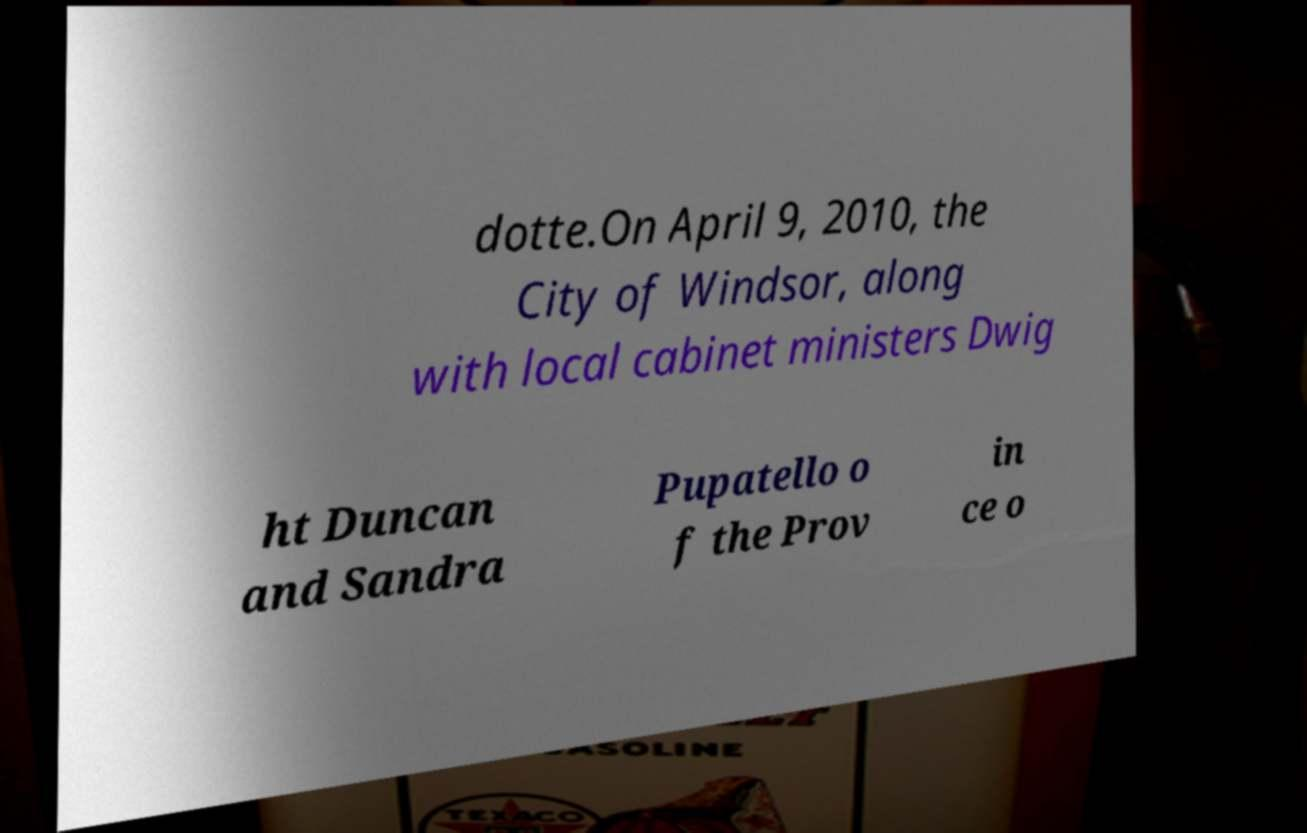Can you accurately transcribe the text from the provided image for me? dotte.On April 9, 2010, the City of Windsor, along with local cabinet ministers Dwig ht Duncan and Sandra Pupatello o f the Prov in ce o 